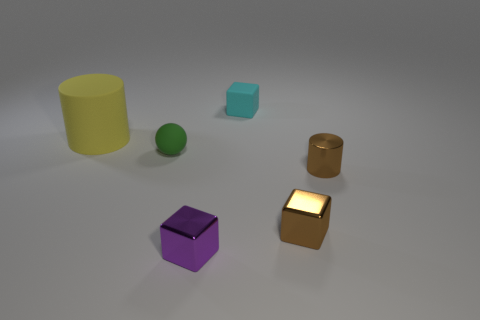Are there fewer purple metal cubes that are behind the purple metal cube than small spheres?
Your answer should be very brief. Yes. Are there any other things that are the same shape as the green object?
Provide a short and direct response. No. What shape is the cyan rubber object right of the large rubber cylinder?
Make the answer very short. Cube. There is a small thing on the left side of the block that is on the left side of the thing that is behind the large matte cylinder; what shape is it?
Your answer should be compact. Sphere. What number of objects are tiny spheres or large rubber things?
Provide a succinct answer. 2. There is a brown shiny object that is left of the metallic cylinder; is its shape the same as the rubber thing on the right side of the tiny purple object?
Your response must be concise. Yes. How many objects are in front of the large yellow thing and on the left side of the cyan cube?
Provide a short and direct response. 2. What number of other things are the same size as the brown cylinder?
Make the answer very short. 4. What is the object that is both behind the small cylinder and right of the small green matte object made of?
Your answer should be compact. Rubber. Do the metal cylinder and the small cube that is right of the rubber cube have the same color?
Offer a very short reply. Yes. 